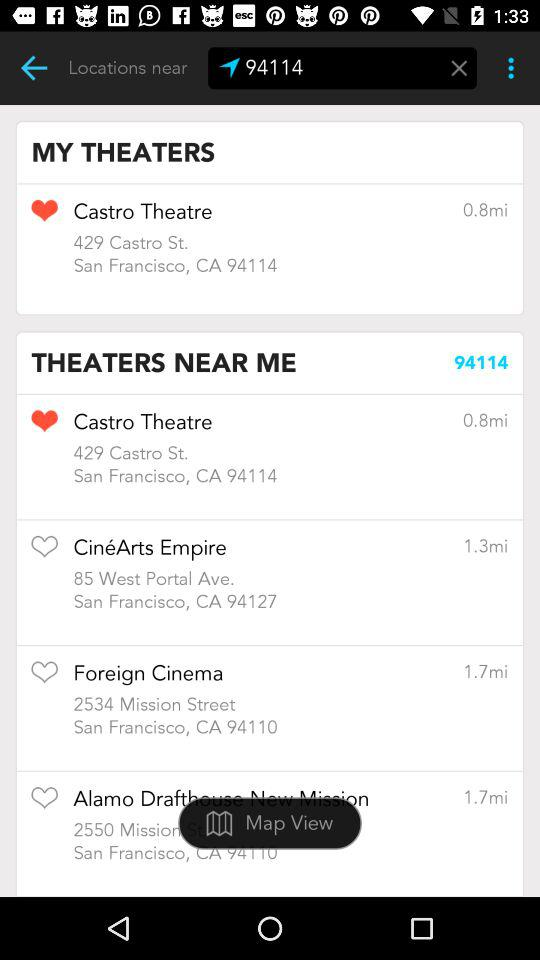Which theater is added to "MY THEATERS"? The theater is Castro Theatre. 